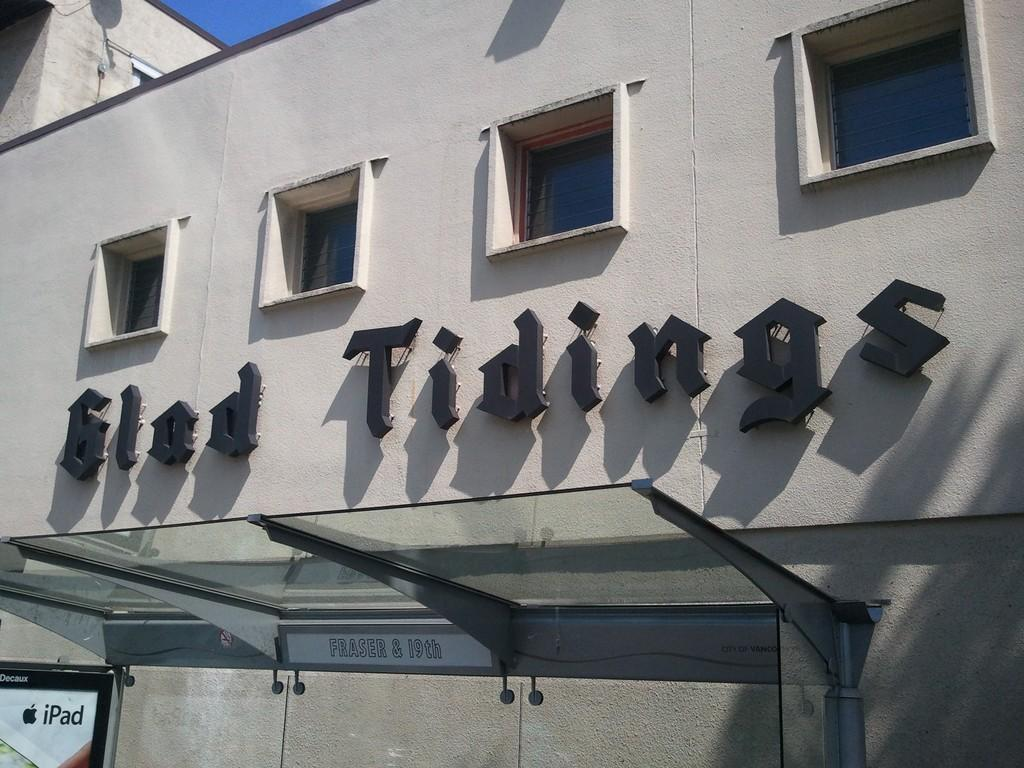What type of structure is in the image? There is a building in the image. What features can be seen on the building? The building has windows and a glass roof. Is there any signage or information displayed on the building? Yes, there is a board on the building with letters on it. Can you see a chicken inside the building? There is no chicken present in the image. 